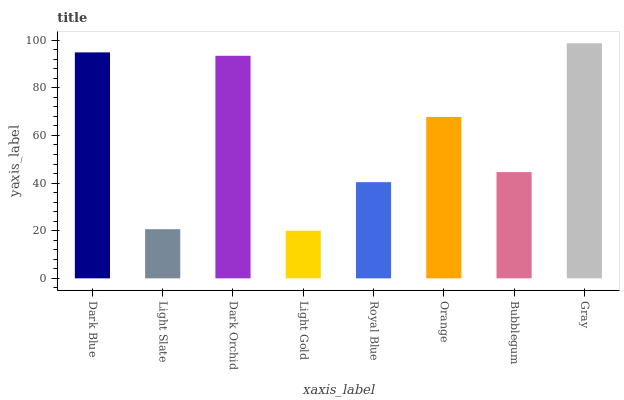Is Light Gold the minimum?
Answer yes or no. Yes. Is Gray the maximum?
Answer yes or no. Yes. Is Light Slate the minimum?
Answer yes or no. No. Is Light Slate the maximum?
Answer yes or no. No. Is Dark Blue greater than Light Slate?
Answer yes or no. Yes. Is Light Slate less than Dark Blue?
Answer yes or no. Yes. Is Light Slate greater than Dark Blue?
Answer yes or no. No. Is Dark Blue less than Light Slate?
Answer yes or no. No. Is Orange the high median?
Answer yes or no. Yes. Is Bubblegum the low median?
Answer yes or no. Yes. Is Royal Blue the high median?
Answer yes or no. No. Is Royal Blue the low median?
Answer yes or no. No. 